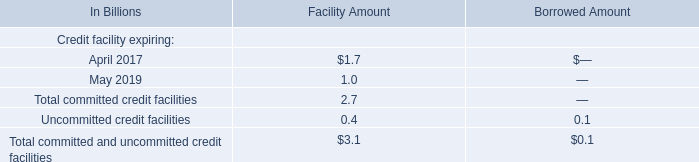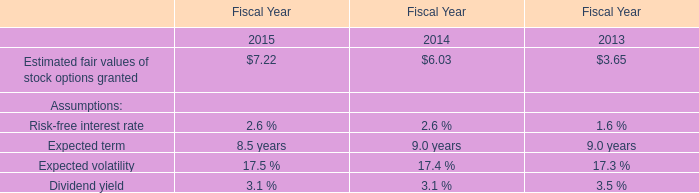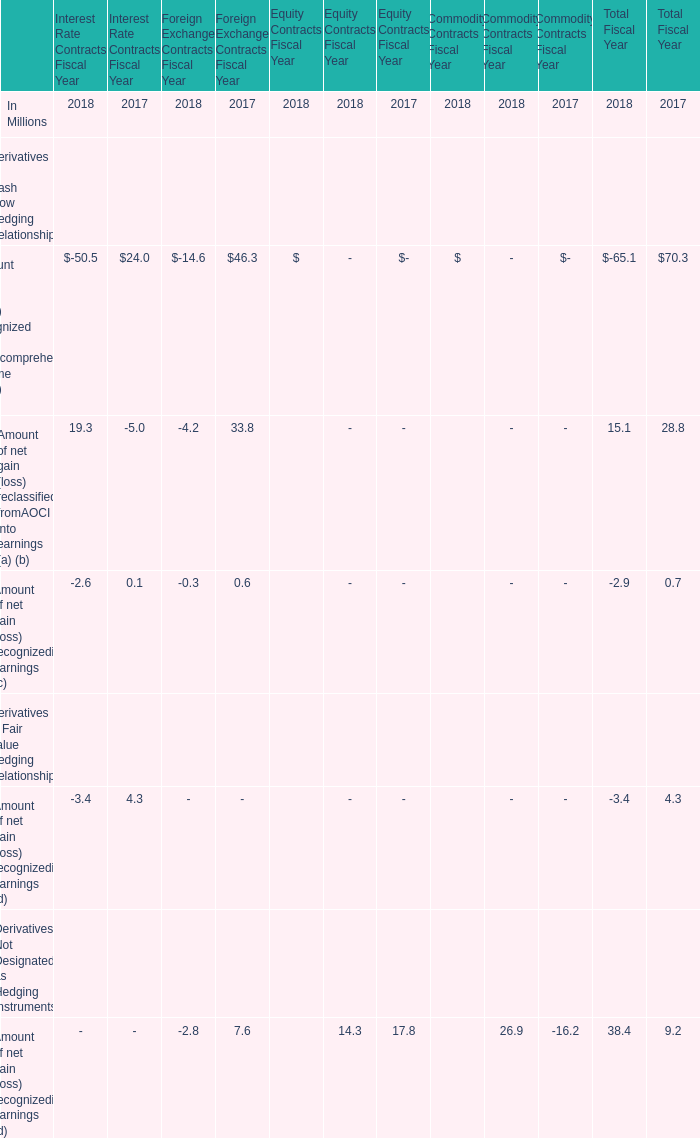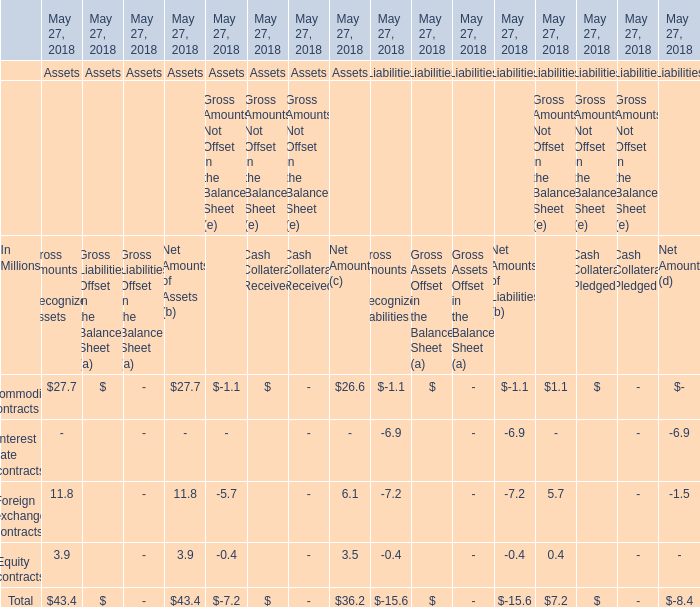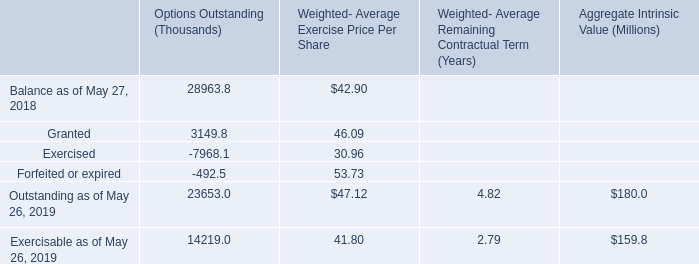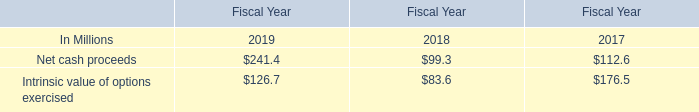What's the Net Amount in terms of Assets for Equity contracts at May 27, 2018? (in million) 
Answer: 3.5. 